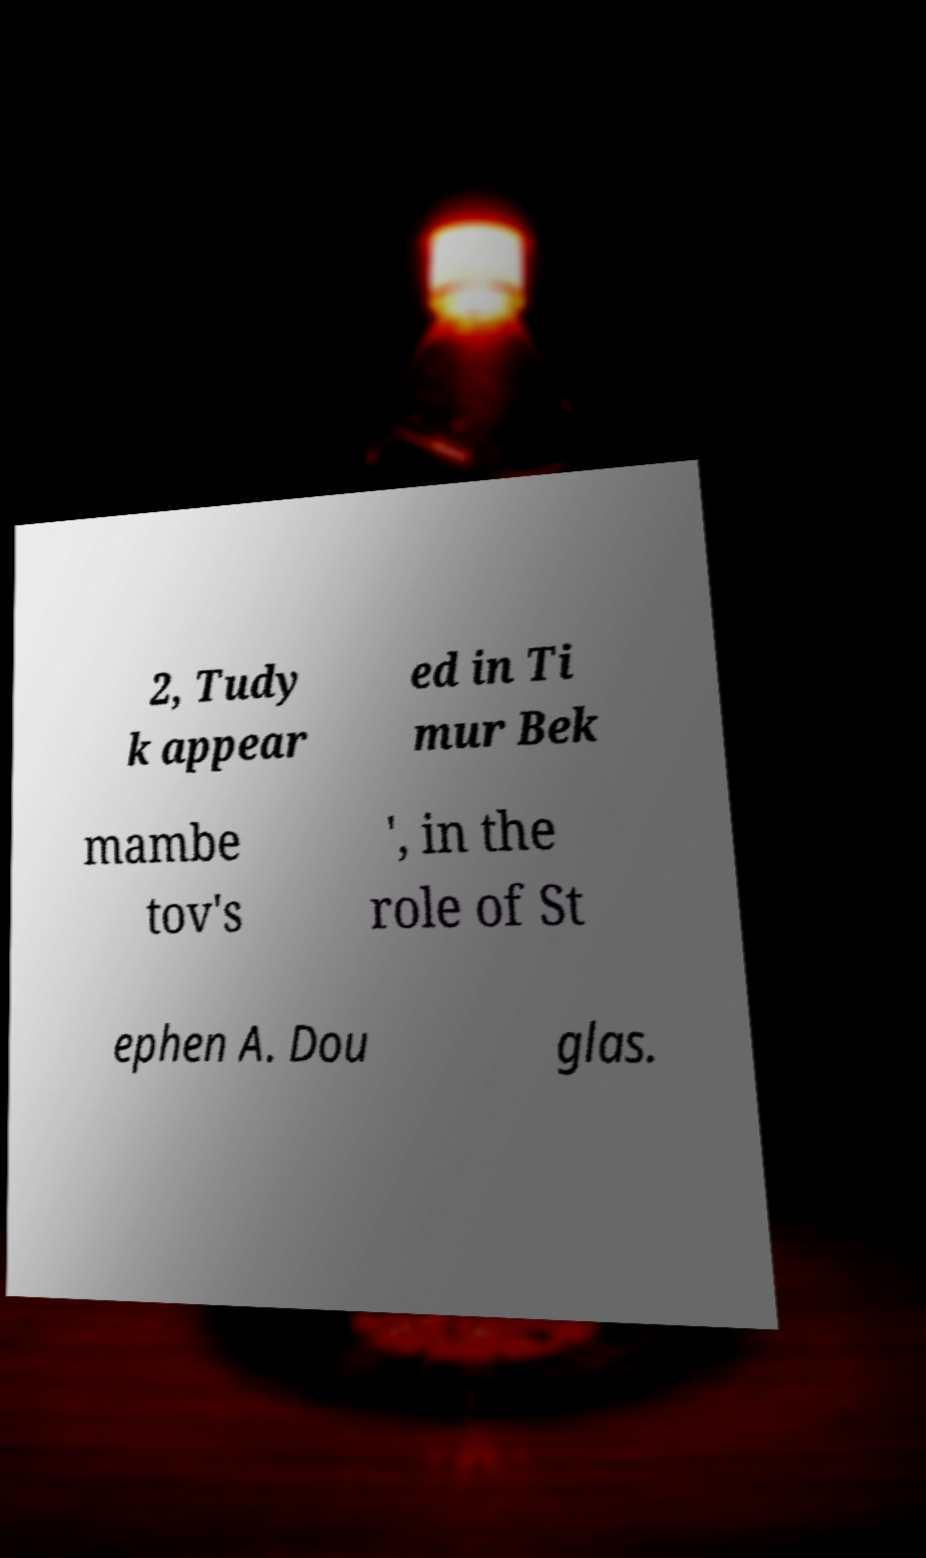There's text embedded in this image that I need extracted. Can you transcribe it verbatim? 2, Tudy k appear ed in Ti mur Bek mambe tov's ', in the role of St ephen A. Dou glas. 